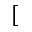Convert formula to latex. <formula><loc_0><loc_0><loc_500><loc_500>[</formula> 